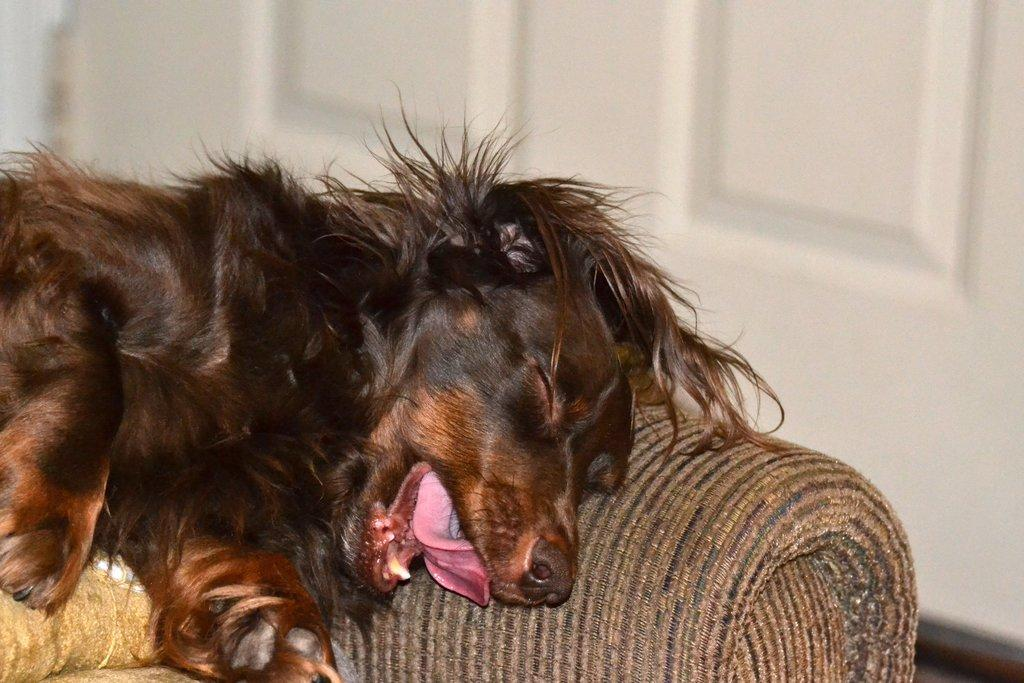What type of animal is in the image? There is a dog in the image. Where is the dog located? The dog is on a couch. What can be seen in the background of the image? There is a wall visible in the background of the image. How many balls are being juggled by the dog in the image? There are no balls present in the image, and the dog is not juggling anything. 